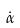Convert formula to latex. <formula><loc_0><loc_0><loc_500><loc_500>\dot { \alpha }</formula> 